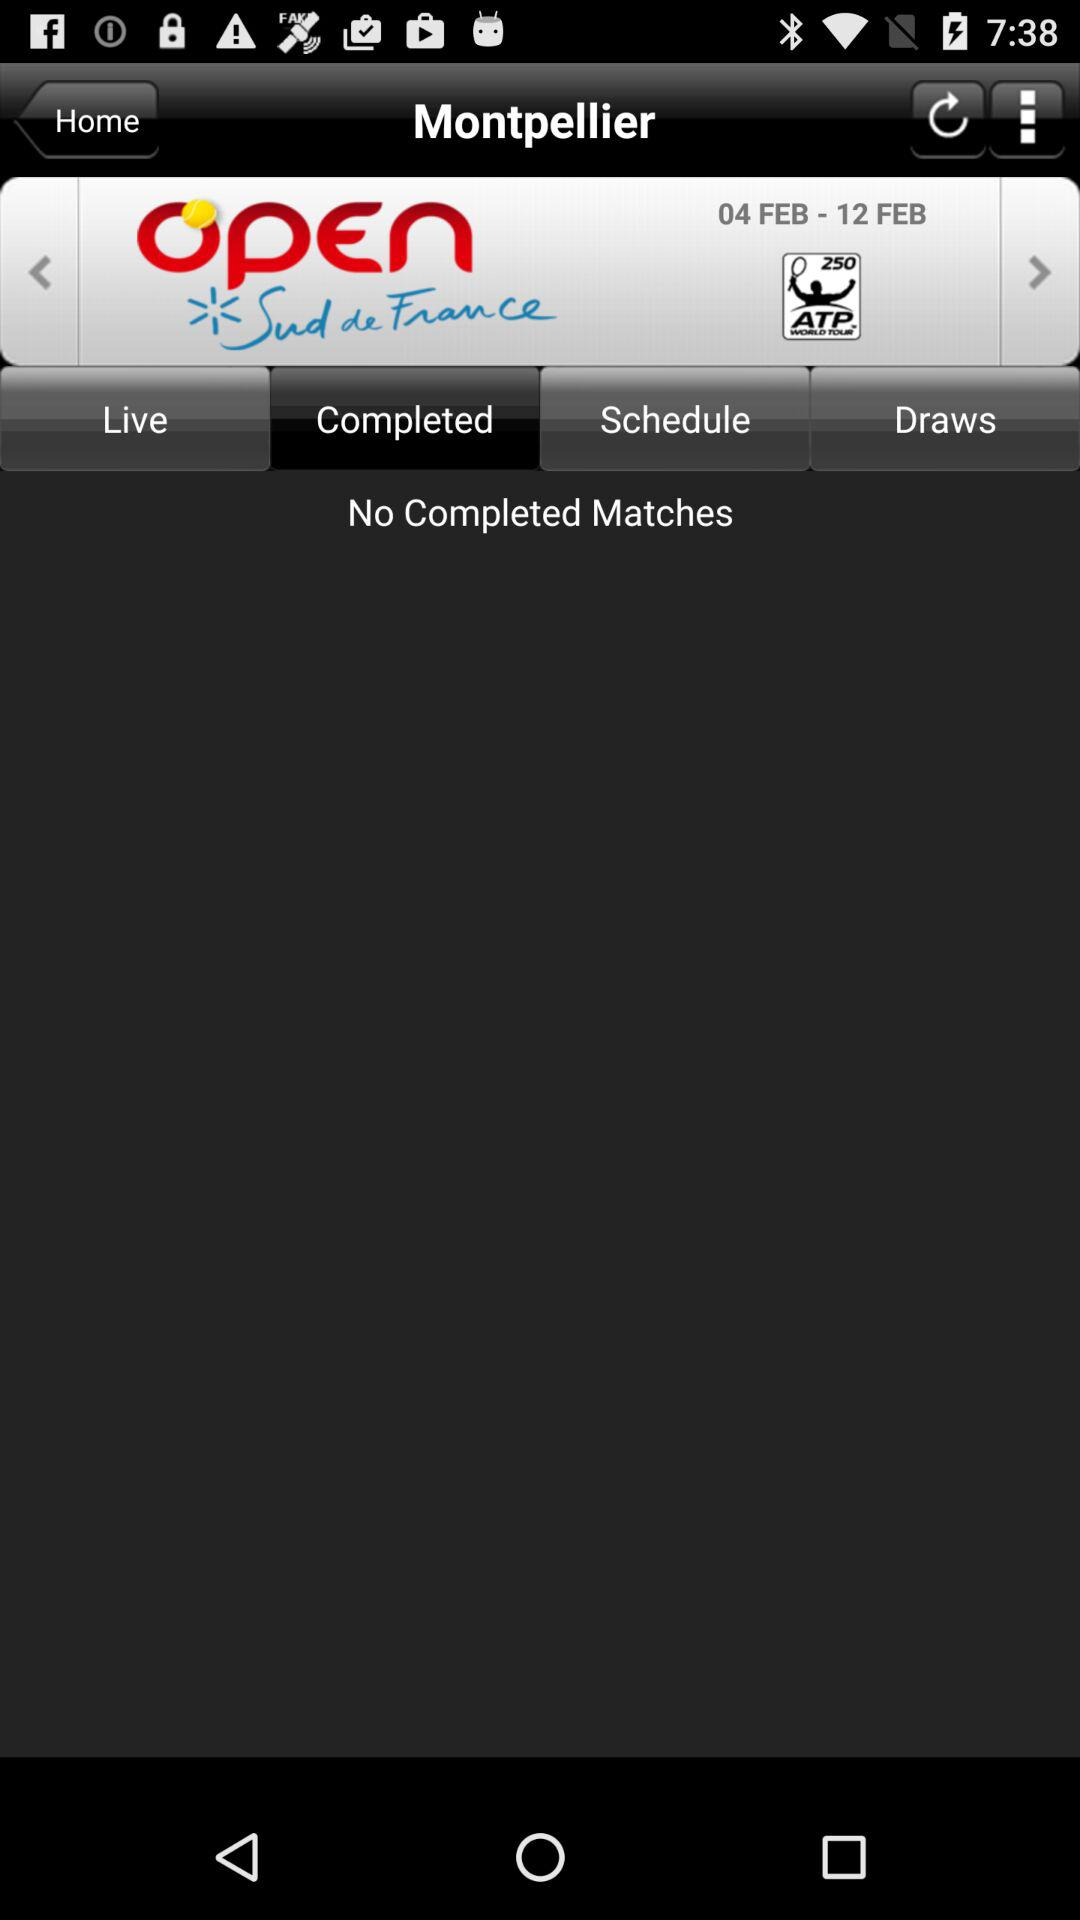What is the mentioned date range? The mentioned date range is from February 4 to February 12. 